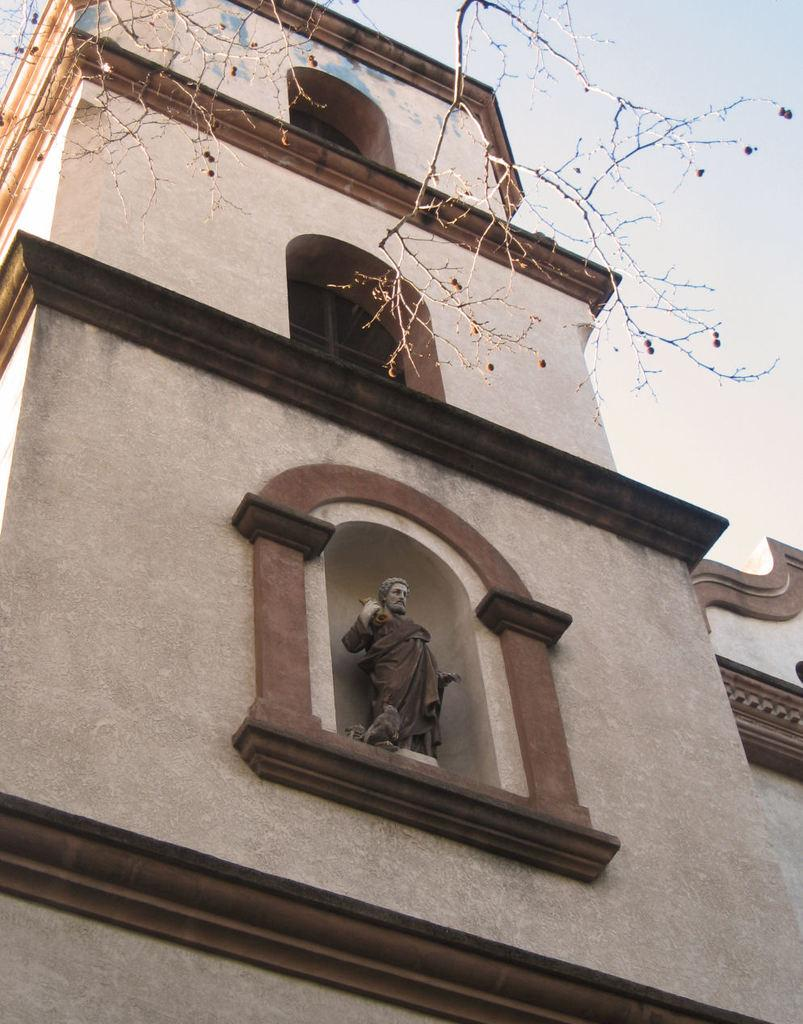What type of structure is present in the image? There is a building in the image. What kind of artwork can be seen in the image? There is a sculpture of a person in the image. What type of plant is visible in the image? There is a tree in the image. What part of the natural environment is visible in the image? The sky is visible in the image. What type of animal is present in the image? There is a bird in the image. How many owls are sitting on the branches of the tree in the image? There are no owls present in the image; only a bird is visible. What type of bottle is being used by the person in the sculpture? There is no bottle present in the image, as the main focus is on the sculpture of a person. 